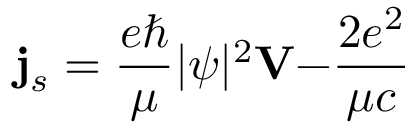<formula> <loc_0><loc_0><loc_500><loc_500>{ j } _ { s } = \frac { e } \mu | \psi | ^ { 2 } { V - } \frac { 2 e ^ { 2 } } { \mu c }</formula> 